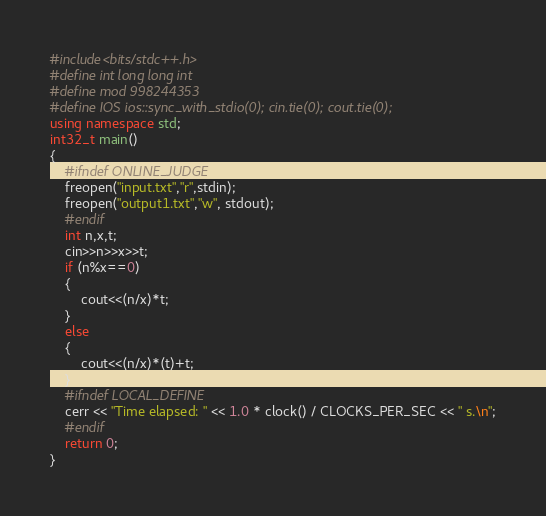<code> <loc_0><loc_0><loc_500><loc_500><_C++_>#include<bits/stdc++.h>
#define int long long int
#define mod 998244353 
#define IOS ios::sync_with_stdio(0); cin.tie(0); cout.tie(0);
using namespace std;
int32_t main()
{
    #ifndef ONLINE_JUDGE
    freopen("input.txt","r",stdin);
    freopen("output1.txt","w", stdout);
    #endif
    int n,x,t;
    cin>>n>>x>>t;
    if (n%x==0)
    {
        cout<<(n/x)*t;
    }
    else
    {
        cout<<(n/x)*(t)+t;
    }
    #ifndef LOCAL_DEFINE
    cerr << "Time elapsed: " << 1.0 * clock() / CLOCKS_PER_SEC << " s.\n";
    #endif
    return 0;
}       </code> 